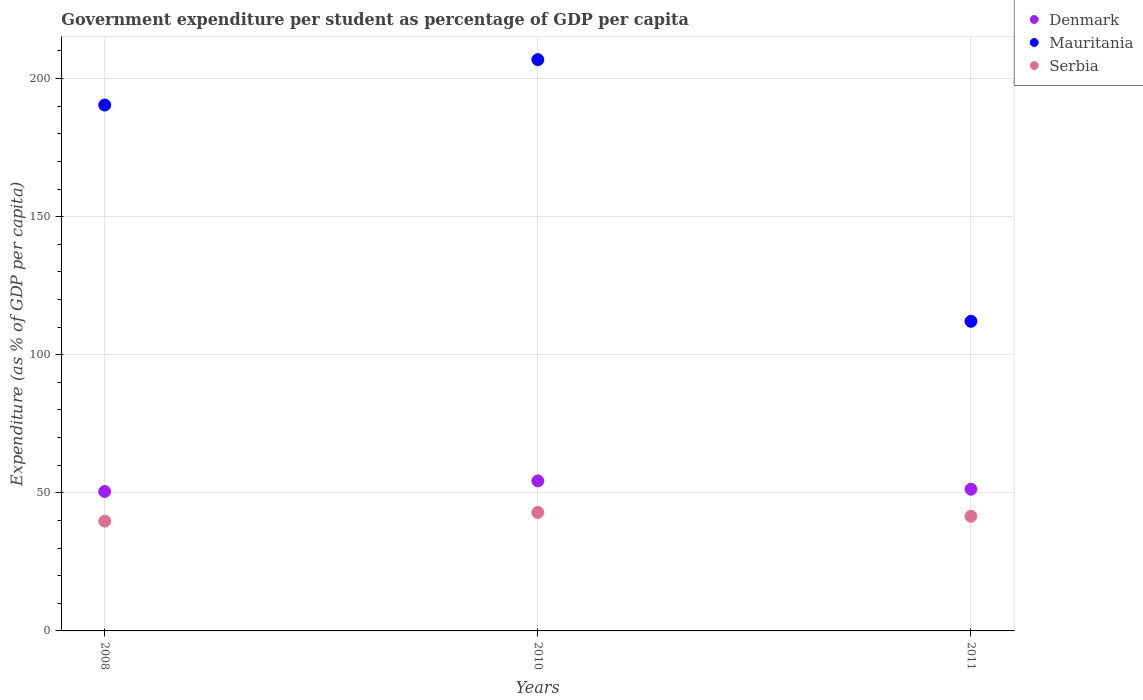Is the number of dotlines equal to the number of legend labels?
Offer a very short reply. Yes. What is the percentage of expenditure per student in Denmark in 2008?
Your answer should be compact. 50.5. Across all years, what is the maximum percentage of expenditure per student in Mauritania?
Provide a short and direct response. 206.85. Across all years, what is the minimum percentage of expenditure per student in Denmark?
Provide a short and direct response. 50.5. What is the total percentage of expenditure per student in Mauritania in the graph?
Provide a short and direct response. 509.38. What is the difference between the percentage of expenditure per student in Denmark in 2010 and that in 2011?
Ensure brevity in your answer.  3.01. What is the difference between the percentage of expenditure per student in Denmark in 2011 and the percentage of expenditure per student in Serbia in 2008?
Offer a very short reply. 11.56. What is the average percentage of expenditure per student in Mauritania per year?
Keep it short and to the point. 169.79. In the year 2008, what is the difference between the percentage of expenditure per student in Denmark and percentage of expenditure per student in Mauritania?
Your response must be concise. -139.92. What is the ratio of the percentage of expenditure per student in Serbia in 2010 to that in 2011?
Provide a succinct answer. 1.03. Is the percentage of expenditure per student in Denmark in 2008 less than that in 2011?
Provide a succinct answer. Yes. Is the difference between the percentage of expenditure per student in Denmark in 2008 and 2010 greater than the difference between the percentage of expenditure per student in Mauritania in 2008 and 2010?
Make the answer very short. Yes. What is the difference between the highest and the second highest percentage of expenditure per student in Mauritania?
Keep it short and to the point. 16.44. What is the difference between the highest and the lowest percentage of expenditure per student in Denmark?
Offer a terse response. 3.82. In how many years, is the percentage of expenditure per student in Denmark greater than the average percentage of expenditure per student in Denmark taken over all years?
Provide a short and direct response. 1. Does the percentage of expenditure per student in Mauritania monotonically increase over the years?
Your answer should be compact. No. Is the percentage of expenditure per student in Serbia strictly less than the percentage of expenditure per student in Mauritania over the years?
Your answer should be compact. Yes. How many years are there in the graph?
Make the answer very short. 3. Does the graph contain any zero values?
Your answer should be compact. No. Where does the legend appear in the graph?
Give a very brief answer. Top right. What is the title of the graph?
Your response must be concise. Government expenditure per student as percentage of GDP per capita. Does "Latin America(developing only)" appear as one of the legend labels in the graph?
Your answer should be very brief. No. What is the label or title of the Y-axis?
Offer a very short reply. Expenditure (as % of GDP per capita). What is the Expenditure (as % of GDP per capita) in Denmark in 2008?
Keep it short and to the point. 50.5. What is the Expenditure (as % of GDP per capita) in Mauritania in 2008?
Give a very brief answer. 190.41. What is the Expenditure (as % of GDP per capita) of Serbia in 2008?
Keep it short and to the point. 39.75. What is the Expenditure (as % of GDP per capita) of Denmark in 2010?
Your answer should be compact. 54.32. What is the Expenditure (as % of GDP per capita) in Mauritania in 2010?
Your answer should be compact. 206.85. What is the Expenditure (as % of GDP per capita) of Serbia in 2010?
Make the answer very short. 42.89. What is the Expenditure (as % of GDP per capita) in Denmark in 2011?
Keep it short and to the point. 51.31. What is the Expenditure (as % of GDP per capita) of Mauritania in 2011?
Offer a terse response. 112.11. What is the Expenditure (as % of GDP per capita) in Serbia in 2011?
Make the answer very short. 41.52. Across all years, what is the maximum Expenditure (as % of GDP per capita) in Denmark?
Give a very brief answer. 54.32. Across all years, what is the maximum Expenditure (as % of GDP per capita) in Mauritania?
Offer a terse response. 206.85. Across all years, what is the maximum Expenditure (as % of GDP per capita) in Serbia?
Offer a terse response. 42.89. Across all years, what is the minimum Expenditure (as % of GDP per capita) of Denmark?
Keep it short and to the point. 50.5. Across all years, what is the minimum Expenditure (as % of GDP per capita) in Mauritania?
Provide a succinct answer. 112.11. Across all years, what is the minimum Expenditure (as % of GDP per capita) of Serbia?
Your response must be concise. 39.75. What is the total Expenditure (as % of GDP per capita) of Denmark in the graph?
Ensure brevity in your answer.  156.13. What is the total Expenditure (as % of GDP per capita) of Mauritania in the graph?
Your answer should be compact. 509.38. What is the total Expenditure (as % of GDP per capita) in Serbia in the graph?
Your response must be concise. 124.16. What is the difference between the Expenditure (as % of GDP per capita) of Denmark in 2008 and that in 2010?
Keep it short and to the point. -3.82. What is the difference between the Expenditure (as % of GDP per capita) in Mauritania in 2008 and that in 2010?
Offer a very short reply. -16.44. What is the difference between the Expenditure (as % of GDP per capita) of Serbia in 2008 and that in 2010?
Offer a very short reply. -3.14. What is the difference between the Expenditure (as % of GDP per capita) in Denmark in 2008 and that in 2011?
Offer a very short reply. -0.81. What is the difference between the Expenditure (as % of GDP per capita) in Mauritania in 2008 and that in 2011?
Provide a short and direct response. 78.3. What is the difference between the Expenditure (as % of GDP per capita) of Serbia in 2008 and that in 2011?
Your response must be concise. -1.76. What is the difference between the Expenditure (as % of GDP per capita) in Denmark in 2010 and that in 2011?
Offer a terse response. 3.01. What is the difference between the Expenditure (as % of GDP per capita) of Mauritania in 2010 and that in 2011?
Make the answer very short. 94.74. What is the difference between the Expenditure (as % of GDP per capita) of Serbia in 2010 and that in 2011?
Keep it short and to the point. 1.37. What is the difference between the Expenditure (as % of GDP per capita) in Denmark in 2008 and the Expenditure (as % of GDP per capita) in Mauritania in 2010?
Make the answer very short. -156.36. What is the difference between the Expenditure (as % of GDP per capita) in Denmark in 2008 and the Expenditure (as % of GDP per capita) in Serbia in 2010?
Provide a short and direct response. 7.61. What is the difference between the Expenditure (as % of GDP per capita) of Mauritania in 2008 and the Expenditure (as % of GDP per capita) of Serbia in 2010?
Offer a very short reply. 147.53. What is the difference between the Expenditure (as % of GDP per capita) of Denmark in 2008 and the Expenditure (as % of GDP per capita) of Mauritania in 2011?
Ensure brevity in your answer.  -61.62. What is the difference between the Expenditure (as % of GDP per capita) in Denmark in 2008 and the Expenditure (as % of GDP per capita) in Serbia in 2011?
Provide a succinct answer. 8.98. What is the difference between the Expenditure (as % of GDP per capita) in Mauritania in 2008 and the Expenditure (as % of GDP per capita) in Serbia in 2011?
Offer a terse response. 148.9. What is the difference between the Expenditure (as % of GDP per capita) in Denmark in 2010 and the Expenditure (as % of GDP per capita) in Mauritania in 2011?
Keep it short and to the point. -57.79. What is the difference between the Expenditure (as % of GDP per capita) in Denmark in 2010 and the Expenditure (as % of GDP per capita) in Serbia in 2011?
Offer a very short reply. 12.8. What is the difference between the Expenditure (as % of GDP per capita) in Mauritania in 2010 and the Expenditure (as % of GDP per capita) in Serbia in 2011?
Provide a short and direct response. 165.34. What is the average Expenditure (as % of GDP per capita) of Denmark per year?
Keep it short and to the point. 52.04. What is the average Expenditure (as % of GDP per capita) in Mauritania per year?
Your answer should be compact. 169.79. What is the average Expenditure (as % of GDP per capita) of Serbia per year?
Keep it short and to the point. 41.39. In the year 2008, what is the difference between the Expenditure (as % of GDP per capita) in Denmark and Expenditure (as % of GDP per capita) in Mauritania?
Give a very brief answer. -139.92. In the year 2008, what is the difference between the Expenditure (as % of GDP per capita) in Denmark and Expenditure (as % of GDP per capita) in Serbia?
Your response must be concise. 10.74. In the year 2008, what is the difference between the Expenditure (as % of GDP per capita) of Mauritania and Expenditure (as % of GDP per capita) of Serbia?
Make the answer very short. 150.66. In the year 2010, what is the difference between the Expenditure (as % of GDP per capita) in Denmark and Expenditure (as % of GDP per capita) in Mauritania?
Keep it short and to the point. -152.53. In the year 2010, what is the difference between the Expenditure (as % of GDP per capita) of Denmark and Expenditure (as % of GDP per capita) of Serbia?
Ensure brevity in your answer.  11.43. In the year 2010, what is the difference between the Expenditure (as % of GDP per capita) in Mauritania and Expenditure (as % of GDP per capita) in Serbia?
Your answer should be compact. 163.96. In the year 2011, what is the difference between the Expenditure (as % of GDP per capita) of Denmark and Expenditure (as % of GDP per capita) of Mauritania?
Your response must be concise. -60.8. In the year 2011, what is the difference between the Expenditure (as % of GDP per capita) of Denmark and Expenditure (as % of GDP per capita) of Serbia?
Provide a succinct answer. 9.79. In the year 2011, what is the difference between the Expenditure (as % of GDP per capita) in Mauritania and Expenditure (as % of GDP per capita) in Serbia?
Your response must be concise. 70.6. What is the ratio of the Expenditure (as % of GDP per capita) in Denmark in 2008 to that in 2010?
Provide a succinct answer. 0.93. What is the ratio of the Expenditure (as % of GDP per capita) of Mauritania in 2008 to that in 2010?
Offer a terse response. 0.92. What is the ratio of the Expenditure (as % of GDP per capita) in Serbia in 2008 to that in 2010?
Ensure brevity in your answer.  0.93. What is the ratio of the Expenditure (as % of GDP per capita) of Denmark in 2008 to that in 2011?
Make the answer very short. 0.98. What is the ratio of the Expenditure (as % of GDP per capita) in Mauritania in 2008 to that in 2011?
Your answer should be compact. 1.7. What is the ratio of the Expenditure (as % of GDP per capita) of Serbia in 2008 to that in 2011?
Ensure brevity in your answer.  0.96. What is the ratio of the Expenditure (as % of GDP per capita) in Denmark in 2010 to that in 2011?
Ensure brevity in your answer.  1.06. What is the ratio of the Expenditure (as % of GDP per capita) in Mauritania in 2010 to that in 2011?
Your answer should be very brief. 1.84. What is the ratio of the Expenditure (as % of GDP per capita) in Serbia in 2010 to that in 2011?
Your answer should be very brief. 1.03. What is the difference between the highest and the second highest Expenditure (as % of GDP per capita) in Denmark?
Provide a succinct answer. 3.01. What is the difference between the highest and the second highest Expenditure (as % of GDP per capita) of Mauritania?
Offer a very short reply. 16.44. What is the difference between the highest and the second highest Expenditure (as % of GDP per capita) of Serbia?
Offer a terse response. 1.37. What is the difference between the highest and the lowest Expenditure (as % of GDP per capita) of Denmark?
Your response must be concise. 3.82. What is the difference between the highest and the lowest Expenditure (as % of GDP per capita) of Mauritania?
Give a very brief answer. 94.74. What is the difference between the highest and the lowest Expenditure (as % of GDP per capita) of Serbia?
Your answer should be compact. 3.14. 